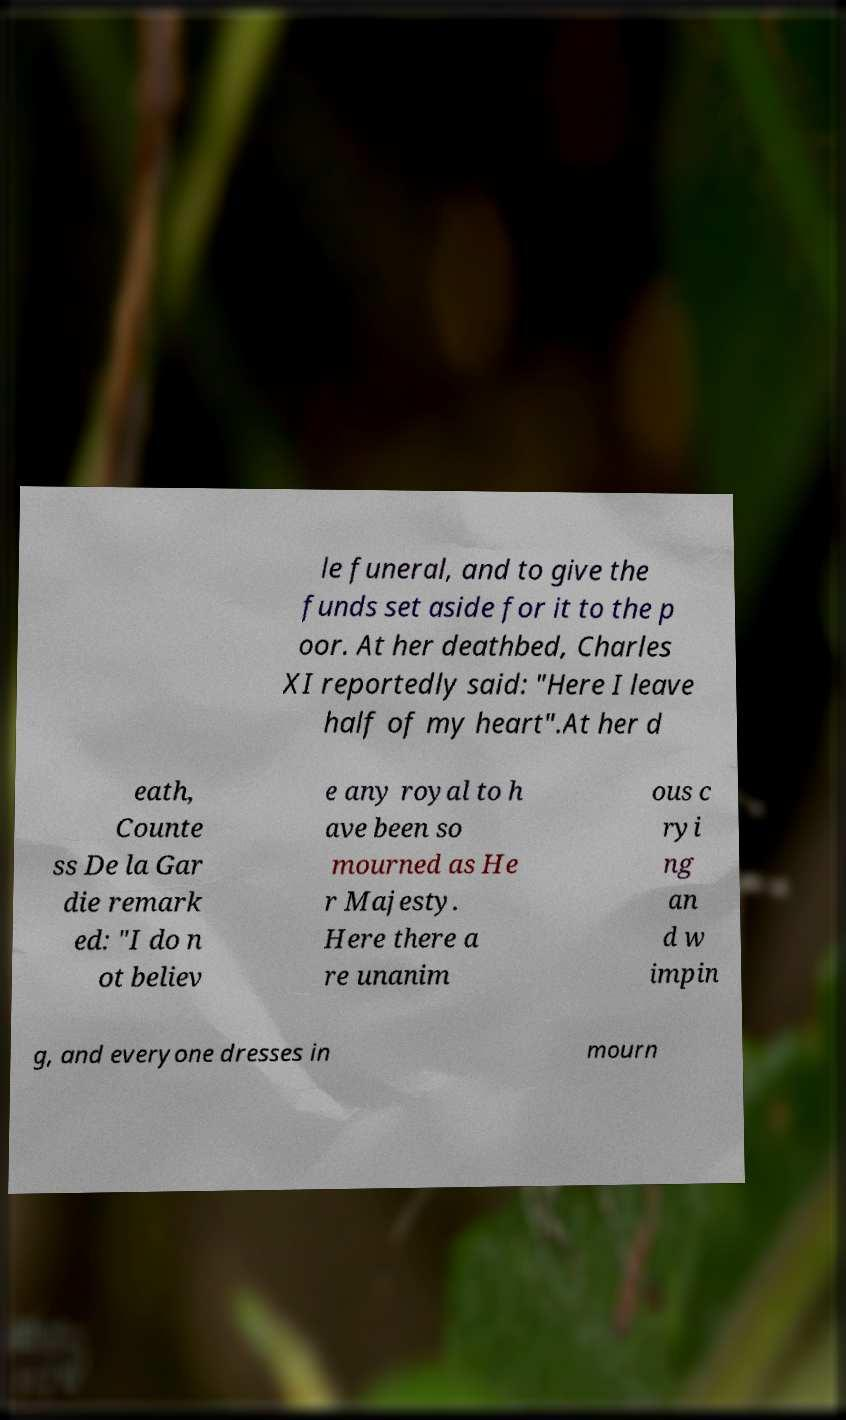I need the written content from this picture converted into text. Can you do that? le funeral, and to give the funds set aside for it to the p oor. At her deathbed, Charles XI reportedly said: "Here I leave half of my heart".At her d eath, Counte ss De la Gar die remark ed: "I do n ot believ e any royal to h ave been so mourned as He r Majesty. Here there a re unanim ous c ryi ng an d w impin g, and everyone dresses in mourn 